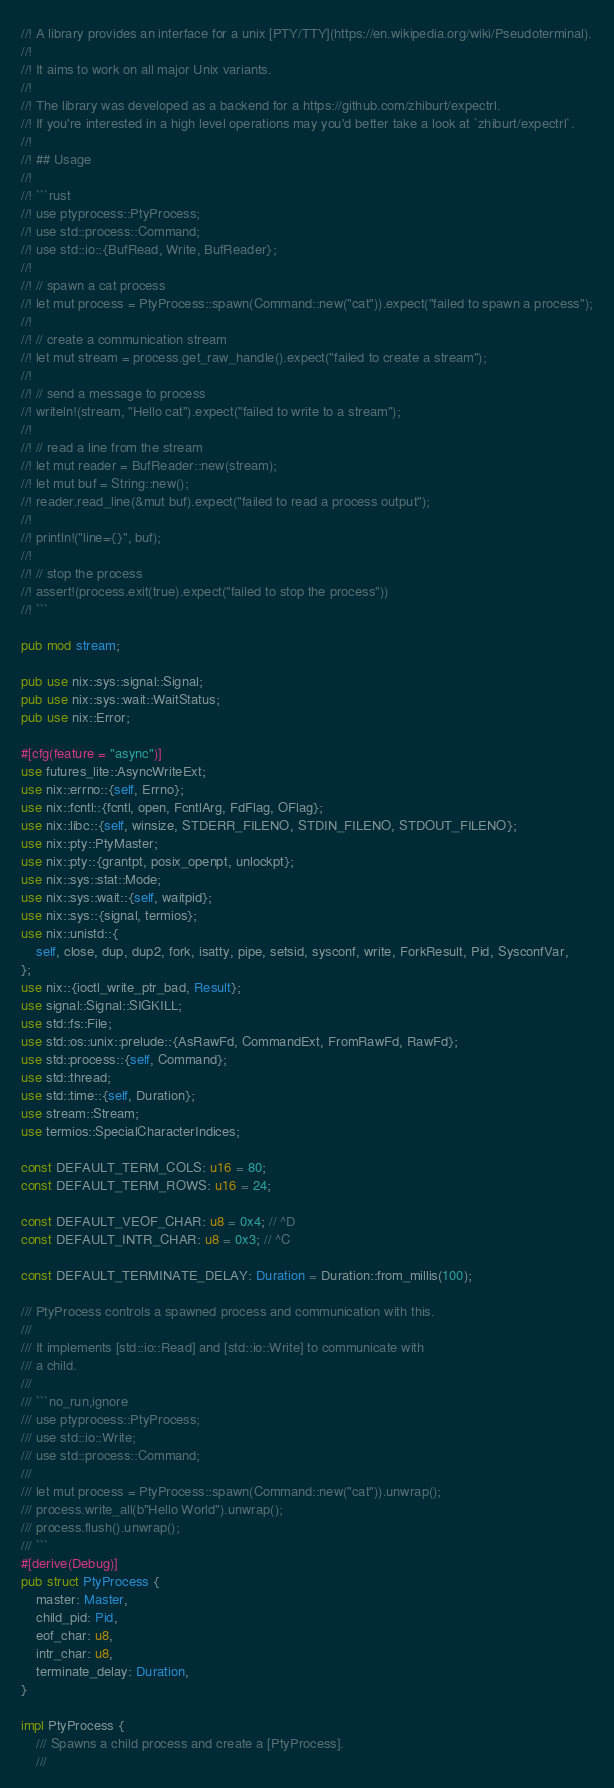Convert code to text. <code><loc_0><loc_0><loc_500><loc_500><_Rust_>//! A library provides an interface for a unix [PTY/TTY](https://en.wikipedia.org/wiki/Pseudoterminal).
//!
//! It aims to work on all major Unix variants.
//!
//! The library was developed as a backend for a https://github.com/zhiburt/expectrl.
//! If you're interested in a high level operations may you'd better take a look at `zhiburt/expectrl`.
//!
//! ## Usage
//!
//! ```rust
//! use ptyprocess::PtyProcess;
//! use std::process::Command;
//! use std::io::{BufRead, Write, BufReader};
//!
//! // spawn a cat process
//! let mut process = PtyProcess::spawn(Command::new("cat")).expect("failed to spawn a process");
//!
//! // create a communication stream
//! let mut stream = process.get_raw_handle().expect("failed to create a stream");
//!
//! // send a message to process
//! writeln!(stream, "Hello cat").expect("failed to write to a stream");
//!
//! // read a line from the stream
//! let mut reader = BufReader::new(stream);
//! let mut buf = String::new();
//! reader.read_line(&mut buf).expect("failed to read a process output");
//!
//! println!("line={}", buf);
//!
//! // stop the process
//! assert!(process.exit(true).expect("failed to stop the process"))
//! ```

pub mod stream;

pub use nix::sys::signal::Signal;
pub use nix::sys::wait::WaitStatus;
pub use nix::Error;

#[cfg(feature = "async")]
use futures_lite::AsyncWriteExt;
use nix::errno::{self, Errno};
use nix::fcntl::{fcntl, open, FcntlArg, FdFlag, OFlag};
use nix::libc::{self, winsize, STDERR_FILENO, STDIN_FILENO, STDOUT_FILENO};
use nix::pty::PtyMaster;
use nix::pty::{grantpt, posix_openpt, unlockpt};
use nix::sys::stat::Mode;
use nix::sys::wait::{self, waitpid};
use nix::sys::{signal, termios};
use nix::unistd::{
    self, close, dup, dup2, fork, isatty, pipe, setsid, sysconf, write, ForkResult, Pid, SysconfVar,
};
use nix::{ioctl_write_ptr_bad, Result};
use signal::Signal::SIGKILL;
use std::fs::File;
use std::os::unix::prelude::{AsRawFd, CommandExt, FromRawFd, RawFd};
use std::process::{self, Command};
use std::thread;
use std::time::{self, Duration};
use stream::Stream;
use termios::SpecialCharacterIndices;

const DEFAULT_TERM_COLS: u16 = 80;
const DEFAULT_TERM_ROWS: u16 = 24;

const DEFAULT_VEOF_CHAR: u8 = 0x4; // ^D
const DEFAULT_INTR_CHAR: u8 = 0x3; // ^C

const DEFAULT_TERMINATE_DELAY: Duration = Duration::from_millis(100);

/// PtyProcess controls a spawned process and communication with this.
///
/// It implements [std::io::Read] and [std::io::Write] to communicate with
/// a child.
///
/// ```no_run,ignore
/// use ptyprocess::PtyProcess;
/// use std::io::Write;
/// use std::process::Command;
///
/// let mut process = PtyProcess::spawn(Command::new("cat")).unwrap();
/// process.write_all(b"Hello World").unwrap();
/// process.flush().unwrap();
/// ```
#[derive(Debug)]
pub struct PtyProcess {
    master: Master,
    child_pid: Pid,
    eof_char: u8,
    intr_char: u8,
    terminate_delay: Duration,
}

impl PtyProcess {
    /// Spawns a child process and create a [PtyProcess].
    ///</code> 